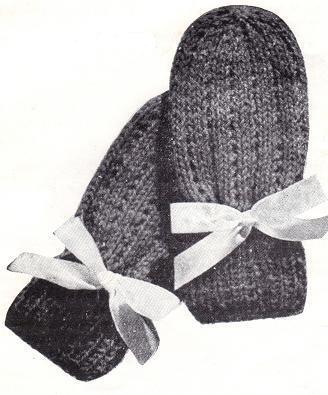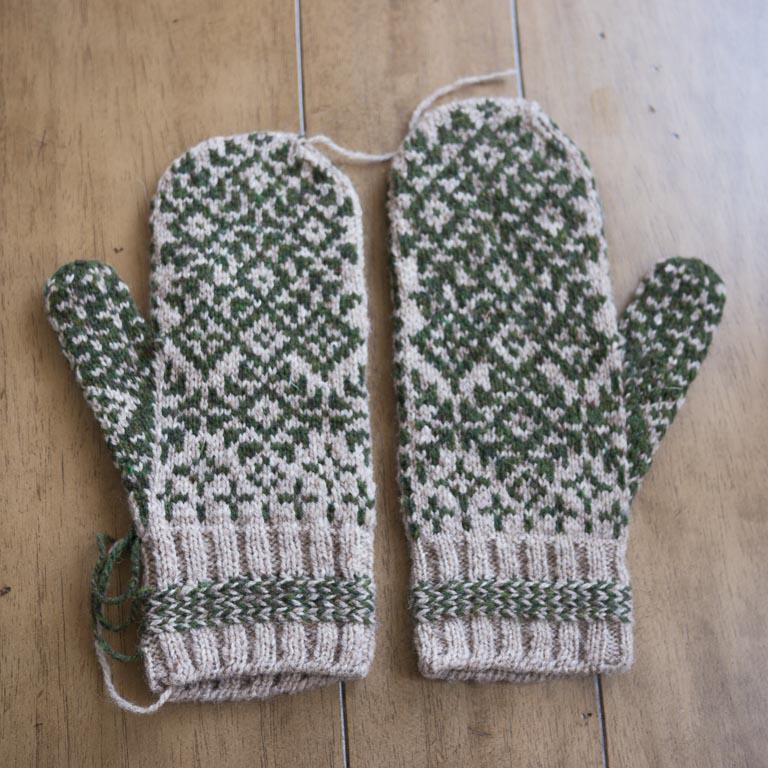The first image is the image on the left, the second image is the image on the right. Assess this claim about the two images: "An image shows a pair of mittens featuring a pattern of vertical stripes and concentric diamonds.". Correct or not? Answer yes or no. No. The first image is the image on the left, the second image is the image on the right. For the images shown, is this caption "Only one mitten is shown in the image on the left." true? Answer yes or no. No. 